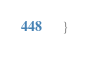Convert code to text. <code><loc_0><loc_0><loc_500><loc_500><_Kotlin_>}
</code> 